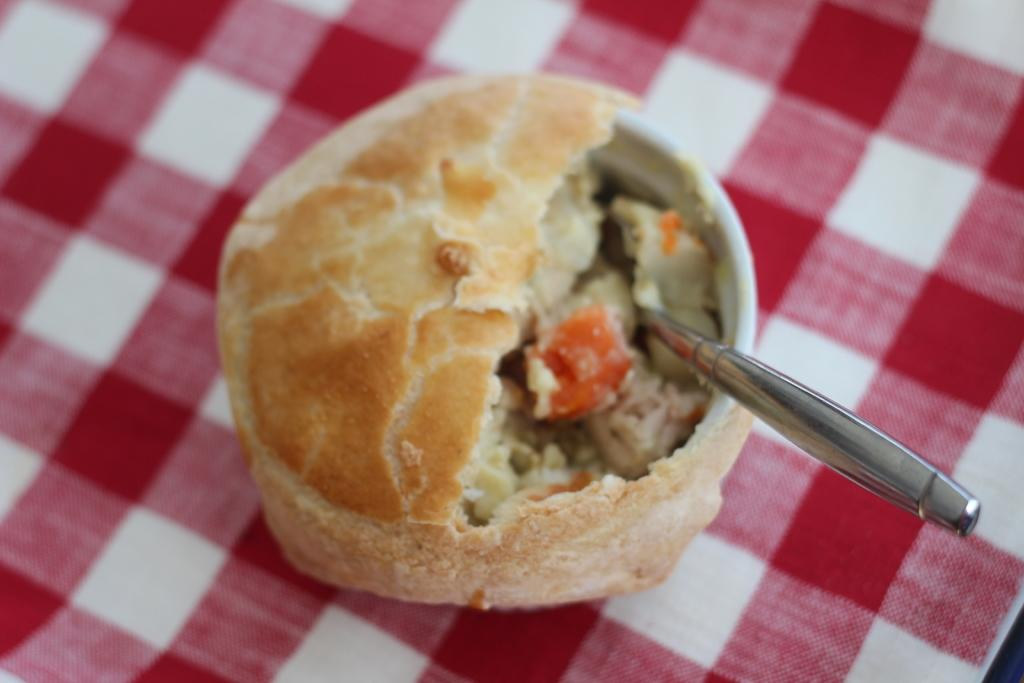What is in the bowl that is visible in the image? There is food in a bowl in the image. What utensil is present in the image? There is a spoon in the image. What type of cloth is at the bottom of the image? There is a red and white check cloth at the bottom of the image. How many trees can be seen in the image? There are no trees present in the image. What type of unit is being measured in the image? There is no unit being measured in the image. 